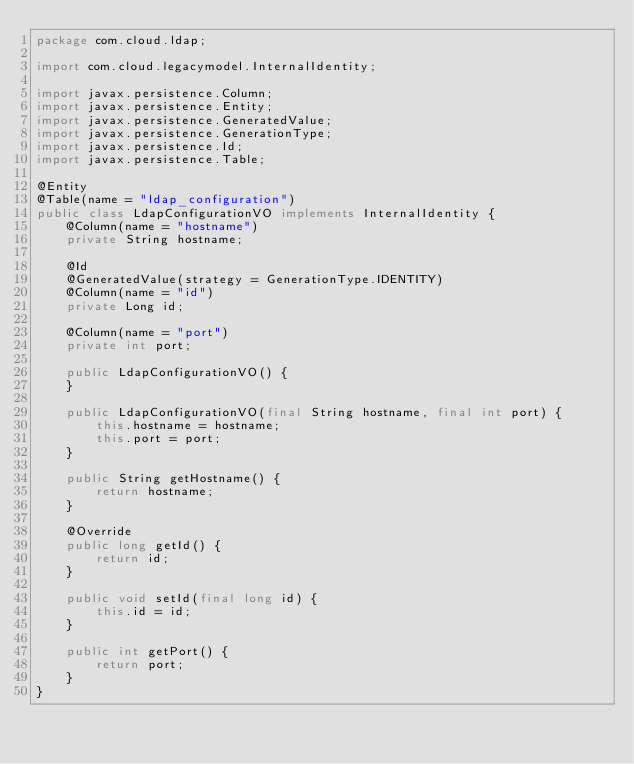Convert code to text. <code><loc_0><loc_0><loc_500><loc_500><_Java_>package com.cloud.ldap;

import com.cloud.legacymodel.InternalIdentity;

import javax.persistence.Column;
import javax.persistence.Entity;
import javax.persistence.GeneratedValue;
import javax.persistence.GenerationType;
import javax.persistence.Id;
import javax.persistence.Table;

@Entity
@Table(name = "ldap_configuration")
public class LdapConfigurationVO implements InternalIdentity {
    @Column(name = "hostname")
    private String hostname;

    @Id
    @GeneratedValue(strategy = GenerationType.IDENTITY)
    @Column(name = "id")
    private Long id;

    @Column(name = "port")
    private int port;

    public LdapConfigurationVO() {
    }

    public LdapConfigurationVO(final String hostname, final int port) {
        this.hostname = hostname;
        this.port = port;
    }

    public String getHostname() {
        return hostname;
    }

    @Override
    public long getId() {
        return id;
    }

    public void setId(final long id) {
        this.id = id;
    }

    public int getPort() {
        return port;
    }
}
</code> 